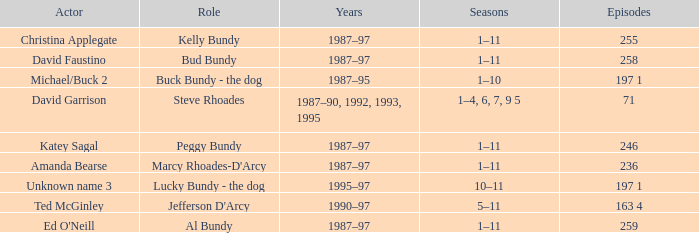How many episodes did the actor David Faustino appear in? 258.0. 